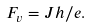Convert formula to latex. <formula><loc_0><loc_0><loc_500><loc_500>F _ { v } = J h / e .</formula> 